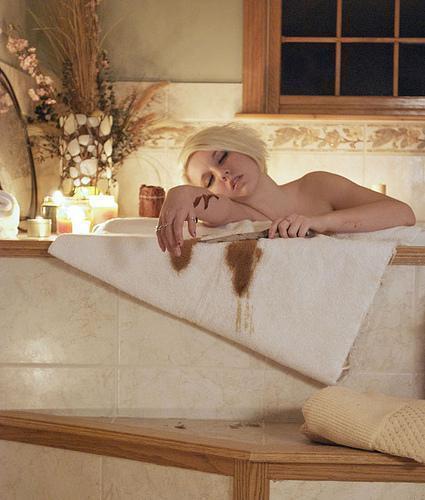How many sinks are to the right of the shower?
Give a very brief answer. 0. 